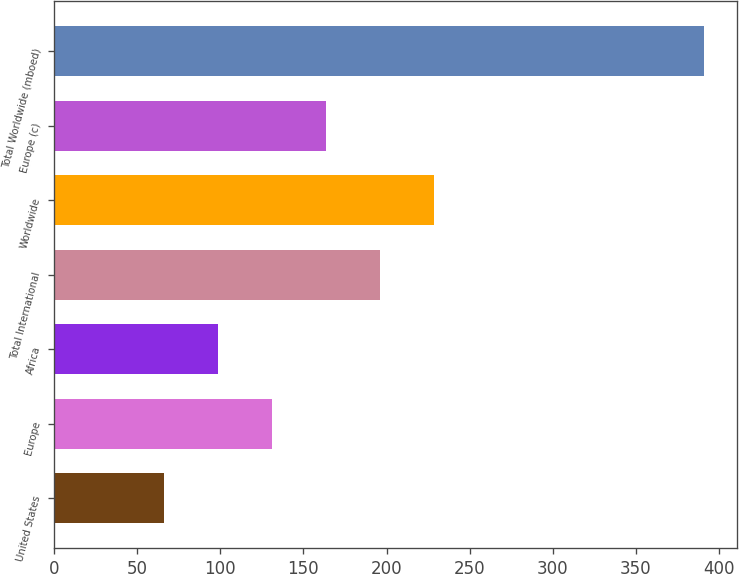<chart> <loc_0><loc_0><loc_500><loc_500><bar_chart><fcel>United States<fcel>Europe<fcel>Africa<fcel>Total International<fcel>Worldwide<fcel>Europe (c)<fcel>Total Worldwide (mboed)<nl><fcel>66<fcel>131<fcel>98.5<fcel>196<fcel>228.5<fcel>163.5<fcel>391<nl></chart> 